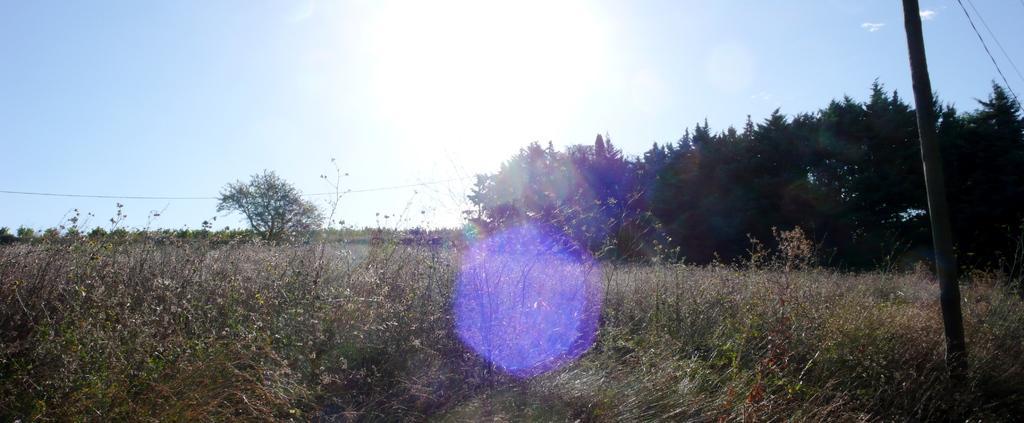In one or two sentences, can you explain what this image depicts? Here we can see grass, plants, pole, and trees. In the background there is sky. 